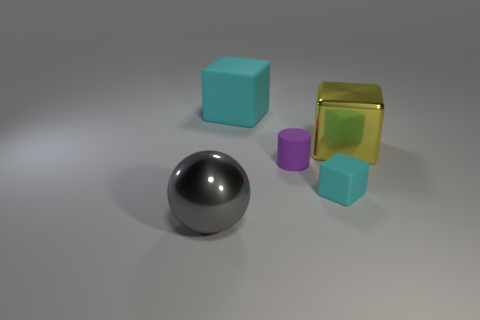The object that is both in front of the tiny purple cylinder and to the left of the tiny matte cube has what shape?
Your response must be concise. Sphere. What size is the purple cylinder that is the same material as the tiny cyan thing?
Keep it short and to the point. Small. What number of things are cyan matte objects behind the tiny cyan block or cubes behind the big yellow block?
Keep it short and to the point. 1. There is a cyan matte thing behind the yellow object; is its size the same as the purple object?
Ensure brevity in your answer.  No. What is the color of the rubber block in front of the metal block?
Give a very brief answer. Cyan. The other matte thing that is the same shape as the tiny cyan matte thing is what color?
Your answer should be compact. Cyan. There is a small matte thing that is on the left side of the rubber cube to the right of the big rubber block; what number of large cubes are on the left side of it?
Keep it short and to the point. 1. Is the number of purple cylinders behind the big matte thing less than the number of large cyan matte objects?
Ensure brevity in your answer.  Yes. Is the color of the big matte object the same as the tiny rubber cube?
Make the answer very short. Yes. What is the size of the other cyan object that is the same shape as the big cyan object?
Give a very brief answer. Small. 